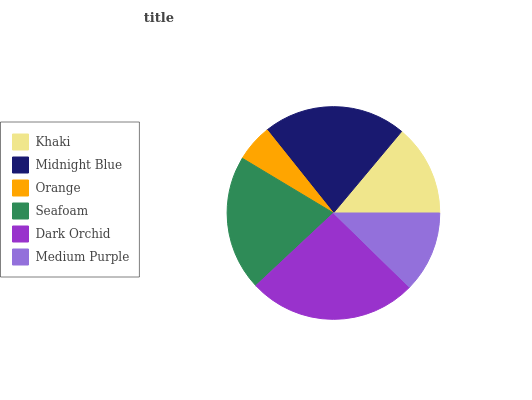Is Orange the minimum?
Answer yes or no. Yes. Is Dark Orchid the maximum?
Answer yes or no. Yes. Is Midnight Blue the minimum?
Answer yes or no. No. Is Midnight Blue the maximum?
Answer yes or no. No. Is Midnight Blue greater than Khaki?
Answer yes or no. Yes. Is Khaki less than Midnight Blue?
Answer yes or no. Yes. Is Khaki greater than Midnight Blue?
Answer yes or no. No. Is Midnight Blue less than Khaki?
Answer yes or no. No. Is Seafoam the high median?
Answer yes or no. Yes. Is Khaki the low median?
Answer yes or no. Yes. Is Medium Purple the high median?
Answer yes or no. No. Is Seafoam the low median?
Answer yes or no. No. 